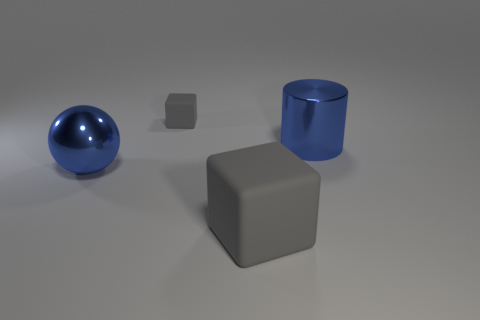What materials do the objects in the image seem to be made from? The sphere and the cylinder appear to have a reflective surface, suggesting they're made of a polished metal or plastic. The two cubes have a matte finish, which could indicate a more absorbent material, like a type of rubber or matte plastic. 